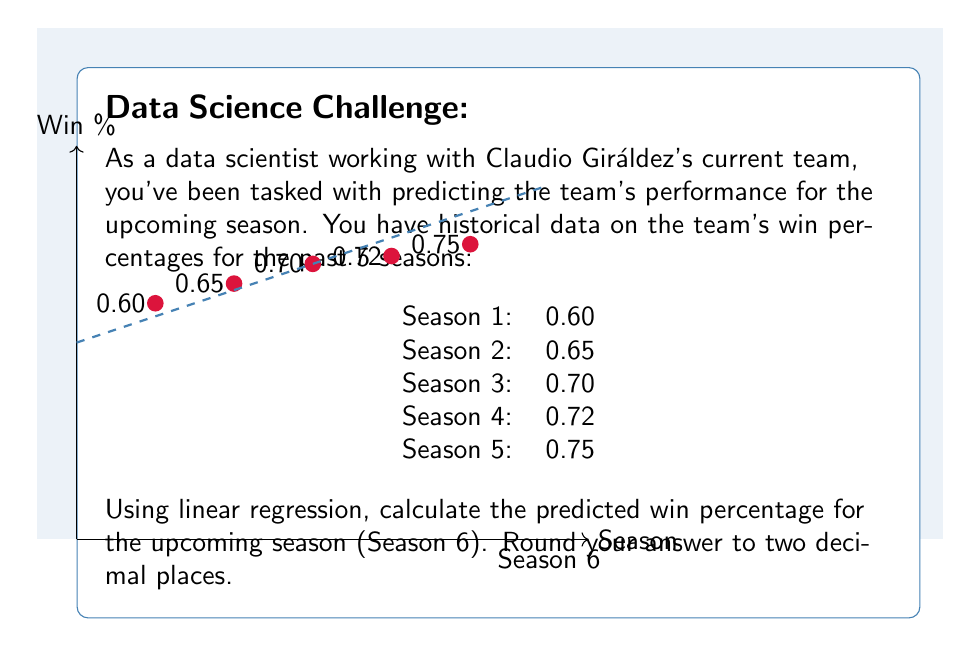Provide a solution to this math problem. To predict the win percentage for Season 6 using linear regression, we'll follow these steps:

1) Let $x$ represent the season number and $y$ represent the win percentage.

2) Calculate the means of $x$ and $y$:
   $\bar{x} = \frac{1+2+3+4+5}{5} = 3$
   $\bar{y} = \frac{0.60+0.65+0.70+0.72+0.75}{5} = 0.684$

3) Calculate the slope ($m$) using the formula:
   $$m = \frac{\sum(x_i - \bar{x})(y_i - \bar{y})}{\sum(x_i - \bar{x})^2}$$

   $\sum(x_i - \bar{x})(y_i - \bar{y}) = (-2)(-0.084) + (-1)(-0.034) + (0)(0.016) + (1)(0.036) + (2)(0.066) = 0.268$
   $\sum(x_i - \bar{x})^2 = (-2)^2 + (-1)^2 + 0^2 + 1^2 + 2^2 = 10$

   $m = \frac{0.268}{10} = 0.0268$

4) Calculate the y-intercept ($b$) using the formula:
   $b = \bar{y} - m\bar{x} = 0.684 - 0.0268(3) = 0.6036$

5) The linear regression equation is:
   $y = mx + b = 0.0268x + 0.6036$

6) To predict the win percentage for Season 6, plug in $x = 6$:
   $y = 0.0268(6) + 0.6036 = 0.7644$

7) Rounding to two decimal places: 0.76
Answer: 0.76 